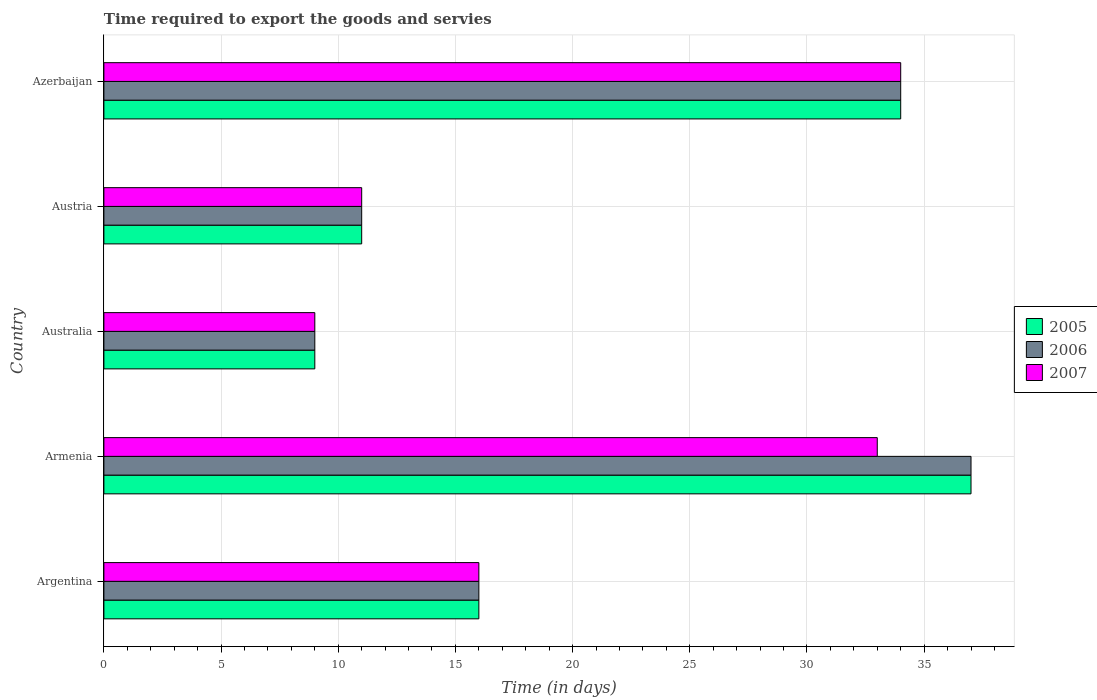How many different coloured bars are there?
Make the answer very short. 3. Are the number of bars per tick equal to the number of legend labels?
Offer a very short reply. Yes. How many bars are there on the 4th tick from the top?
Make the answer very short. 3. How many bars are there on the 4th tick from the bottom?
Provide a succinct answer. 3. What is the label of the 4th group of bars from the top?
Your answer should be compact. Armenia. What is the number of days required to export the goods and services in 2005 in Australia?
Your response must be concise. 9. In which country was the number of days required to export the goods and services in 2007 maximum?
Your answer should be compact. Azerbaijan. What is the total number of days required to export the goods and services in 2005 in the graph?
Your response must be concise. 107. What is the difference between the number of days required to export the goods and services in 2005 in Argentina and that in Australia?
Give a very brief answer. 7. What is the average number of days required to export the goods and services in 2006 per country?
Your answer should be very brief. 21.4. In how many countries, is the number of days required to export the goods and services in 2006 greater than 18 days?
Give a very brief answer. 2. What is the ratio of the number of days required to export the goods and services in 2006 in Argentina to that in Australia?
Your answer should be compact. 1.78. What is the difference between the highest and the second highest number of days required to export the goods and services in 2006?
Ensure brevity in your answer.  3. In how many countries, is the number of days required to export the goods and services in 2006 greater than the average number of days required to export the goods and services in 2006 taken over all countries?
Provide a succinct answer. 2. What does the 1st bar from the bottom in Australia represents?
Offer a very short reply. 2005. Is it the case that in every country, the sum of the number of days required to export the goods and services in 2007 and number of days required to export the goods and services in 2006 is greater than the number of days required to export the goods and services in 2005?
Make the answer very short. Yes. How many countries are there in the graph?
Offer a very short reply. 5. Does the graph contain any zero values?
Keep it short and to the point. No. Does the graph contain grids?
Provide a short and direct response. Yes. Where does the legend appear in the graph?
Your response must be concise. Center right. How are the legend labels stacked?
Give a very brief answer. Vertical. What is the title of the graph?
Give a very brief answer. Time required to export the goods and servies. Does "1970" appear as one of the legend labels in the graph?
Make the answer very short. No. What is the label or title of the X-axis?
Make the answer very short. Time (in days). What is the label or title of the Y-axis?
Offer a very short reply. Country. What is the Time (in days) of 2005 in Armenia?
Provide a short and direct response. 37. What is the Time (in days) of 2007 in Armenia?
Offer a terse response. 33. What is the Time (in days) of 2006 in Australia?
Give a very brief answer. 9. What is the Time (in days) in 2005 in Austria?
Your answer should be very brief. 11. What is the Time (in days) of 2007 in Austria?
Your answer should be very brief. 11. What is the Time (in days) in 2007 in Azerbaijan?
Keep it short and to the point. 34. Across all countries, what is the maximum Time (in days) of 2005?
Give a very brief answer. 37. Across all countries, what is the maximum Time (in days) of 2007?
Offer a terse response. 34. Across all countries, what is the minimum Time (in days) of 2005?
Your answer should be compact. 9. Across all countries, what is the minimum Time (in days) in 2007?
Make the answer very short. 9. What is the total Time (in days) of 2005 in the graph?
Make the answer very short. 107. What is the total Time (in days) in 2006 in the graph?
Ensure brevity in your answer.  107. What is the total Time (in days) of 2007 in the graph?
Keep it short and to the point. 103. What is the difference between the Time (in days) in 2005 in Argentina and that in Armenia?
Offer a very short reply. -21. What is the difference between the Time (in days) of 2007 in Argentina and that in Armenia?
Give a very brief answer. -17. What is the difference between the Time (in days) in 2005 in Argentina and that in Australia?
Provide a short and direct response. 7. What is the difference between the Time (in days) of 2006 in Argentina and that in Australia?
Ensure brevity in your answer.  7. What is the difference between the Time (in days) in 2007 in Argentina and that in Australia?
Give a very brief answer. 7. What is the difference between the Time (in days) in 2005 in Argentina and that in Austria?
Keep it short and to the point. 5. What is the difference between the Time (in days) of 2006 in Argentina and that in Austria?
Your response must be concise. 5. What is the difference between the Time (in days) in 2007 in Argentina and that in Austria?
Provide a succinct answer. 5. What is the difference between the Time (in days) in 2007 in Armenia and that in Australia?
Offer a very short reply. 24. What is the difference between the Time (in days) of 2007 in Armenia and that in Austria?
Make the answer very short. 22. What is the difference between the Time (in days) in 2007 in Armenia and that in Azerbaijan?
Your answer should be very brief. -1. What is the difference between the Time (in days) in 2005 in Australia and that in Austria?
Provide a succinct answer. -2. What is the difference between the Time (in days) of 2005 in Australia and that in Azerbaijan?
Offer a terse response. -25. What is the difference between the Time (in days) in 2007 in Australia and that in Azerbaijan?
Offer a very short reply. -25. What is the difference between the Time (in days) in 2005 in Austria and that in Azerbaijan?
Your answer should be very brief. -23. What is the difference between the Time (in days) of 2007 in Austria and that in Azerbaijan?
Keep it short and to the point. -23. What is the difference between the Time (in days) of 2005 in Argentina and the Time (in days) of 2006 in Armenia?
Offer a terse response. -21. What is the difference between the Time (in days) in 2006 in Argentina and the Time (in days) in 2007 in Armenia?
Keep it short and to the point. -17. What is the difference between the Time (in days) of 2005 in Argentina and the Time (in days) of 2006 in Australia?
Your answer should be compact. 7. What is the difference between the Time (in days) in 2005 in Argentina and the Time (in days) in 2007 in Australia?
Your answer should be very brief. 7. What is the difference between the Time (in days) of 2006 in Argentina and the Time (in days) of 2007 in Australia?
Keep it short and to the point. 7. What is the difference between the Time (in days) of 2005 in Argentina and the Time (in days) of 2006 in Austria?
Your answer should be compact. 5. What is the difference between the Time (in days) in 2006 in Argentina and the Time (in days) in 2007 in Austria?
Offer a very short reply. 5. What is the difference between the Time (in days) of 2006 in Argentina and the Time (in days) of 2007 in Azerbaijan?
Keep it short and to the point. -18. What is the difference between the Time (in days) in 2005 in Armenia and the Time (in days) in 2006 in Australia?
Your answer should be compact. 28. What is the difference between the Time (in days) in 2005 in Armenia and the Time (in days) in 2007 in Austria?
Your response must be concise. 26. What is the difference between the Time (in days) of 2005 in Armenia and the Time (in days) of 2006 in Azerbaijan?
Your answer should be compact. 3. What is the difference between the Time (in days) of 2005 in Armenia and the Time (in days) of 2007 in Azerbaijan?
Provide a short and direct response. 3. What is the difference between the Time (in days) in 2006 in Australia and the Time (in days) in 2007 in Austria?
Your answer should be very brief. -2. What is the difference between the Time (in days) in 2005 in Australia and the Time (in days) in 2007 in Azerbaijan?
Provide a short and direct response. -25. What is the difference between the Time (in days) in 2005 in Austria and the Time (in days) in 2006 in Azerbaijan?
Give a very brief answer. -23. What is the difference between the Time (in days) of 2005 in Austria and the Time (in days) of 2007 in Azerbaijan?
Provide a short and direct response. -23. What is the average Time (in days) of 2005 per country?
Provide a short and direct response. 21.4. What is the average Time (in days) in 2006 per country?
Give a very brief answer. 21.4. What is the average Time (in days) of 2007 per country?
Provide a short and direct response. 20.6. What is the difference between the Time (in days) in 2005 and Time (in days) in 2006 in Argentina?
Your answer should be compact. 0. What is the difference between the Time (in days) of 2005 and Time (in days) of 2007 in Argentina?
Offer a terse response. 0. What is the difference between the Time (in days) in 2006 and Time (in days) in 2007 in Argentina?
Keep it short and to the point. 0. What is the difference between the Time (in days) of 2006 and Time (in days) of 2007 in Armenia?
Keep it short and to the point. 4. What is the difference between the Time (in days) of 2005 and Time (in days) of 2006 in Australia?
Keep it short and to the point. 0. What is the difference between the Time (in days) of 2005 and Time (in days) of 2007 in Australia?
Offer a terse response. 0. What is the difference between the Time (in days) of 2006 and Time (in days) of 2007 in Australia?
Your answer should be compact. 0. What is the difference between the Time (in days) in 2005 and Time (in days) in 2006 in Austria?
Offer a very short reply. 0. What is the difference between the Time (in days) of 2006 and Time (in days) of 2007 in Austria?
Give a very brief answer. 0. What is the difference between the Time (in days) in 2005 and Time (in days) in 2006 in Azerbaijan?
Provide a succinct answer. 0. What is the difference between the Time (in days) in 2005 and Time (in days) in 2007 in Azerbaijan?
Offer a very short reply. 0. What is the difference between the Time (in days) of 2006 and Time (in days) of 2007 in Azerbaijan?
Keep it short and to the point. 0. What is the ratio of the Time (in days) in 2005 in Argentina to that in Armenia?
Provide a short and direct response. 0.43. What is the ratio of the Time (in days) of 2006 in Argentina to that in Armenia?
Make the answer very short. 0.43. What is the ratio of the Time (in days) in 2007 in Argentina to that in Armenia?
Your answer should be compact. 0.48. What is the ratio of the Time (in days) of 2005 in Argentina to that in Australia?
Offer a very short reply. 1.78. What is the ratio of the Time (in days) in 2006 in Argentina to that in Australia?
Provide a succinct answer. 1.78. What is the ratio of the Time (in days) of 2007 in Argentina to that in Australia?
Keep it short and to the point. 1.78. What is the ratio of the Time (in days) in 2005 in Argentina to that in Austria?
Keep it short and to the point. 1.45. What is the ratio of the Time (in days) of 2006 in Argentina to that in Austria?
Your response must be concise. 1.45. What is the ratio of the Time (in days) in 2007 in Argentina to that in Austria?
Give a very brief answer. 1.45. What is the ratio of the Time (in days) in 2005 in Argentina to that in Azerbaijan?
Keep it short and to the point. 0.47. What is the ratio of the Time (in days) of 2006 in Argentina to that in Azerbaijan?
Make the answer very short. 0.47. What is the ratio of the Time (in days) of 2007 in Argentina to that in Azerbaijan?
Keep it short and to the point. 0.47. What is the ratio of the Time (in days) in 2005 in Armenia to that in Australia?
Your answer should be compact. 4.11. What is the ratio of the Time (in days) of 2006 in Armenia to that in Australia?
Your answer should be very brief. 4.11. What is the ratio of the Time (in days) of 2007 in Armenia to that in Australia?
Offer a very short reply. 3.67. What is the ratio of the Time (in days) of 2005 in Armenia to that in Austria?
Give a very brief answer. 3.36. What is the ratio of the Time (in days) in 2006 in Armenia to that in Austria?
Provide a short and direct response. 3.36. What is the ratio of the Time (in days) in 2007 in Armenia to that in Austria?
Your answer should be very brief. 3. What is the ratio of the Time (in days) in 2005 in Armenia to that in Azerbaijan?
Provide a succinct answer. 1.09. What is the ratio of the Time (in days) of 2006 in Armenia to that in Azerbaijan?
Offer a terse response. 1.09. What is the ratio of the Time (in days) of 2007 in Armenia to that in Azerbaijan?
Make the answer very short. 0.97. What is the ratio of the Time (in days) of 2005 in Australia to that in Austria?
Make the answer very short. 0.82. What is the ratio of the Time (in days) of 2006 in Australia to that in Austria?
Offer a terse response. 0.82. What is the ratio of the Time (in days) of 2007 in Australia to that in Austria?
Provide a succinct answer. 0.82. What is the ratio of the Time (in days) of 2005 in Australia to that in Azerbaijan?
Your response must be concise. 0.26. What is the ratio of the Time (in days) of 2006 in Australia to that in Azerbaijan?
Give a very brief answer. 0.26. What is the ratio of the Time (in days) of 2007 in Australia to that in Azerbaijan?
Offer a very short reply. 0.26. What is the ratio of the Time (in days) of 2005 in Austria to that in Azerbaijan?
Your response must be concise. 0.32. What is the ratio of the Time (in days) of 2006 in Austria to that in Azerbaijan?
Offer a very short reply. 0.32. What is the ratio of the Time (in days) of 2007 in Austria to that in Azerbaijan?
Provide a short and direct response. 0.32. What is the difference between the highest and the second highest Time (in days) in 2005?
Your response must be concise. 3. What is the difference between the highest and the second highest Time (in days) in 2006?
Your answer should be very brief. 3. What is the difference between the highest and the lowest Time (in days) in 2005?
Make the answer very short. 28. 